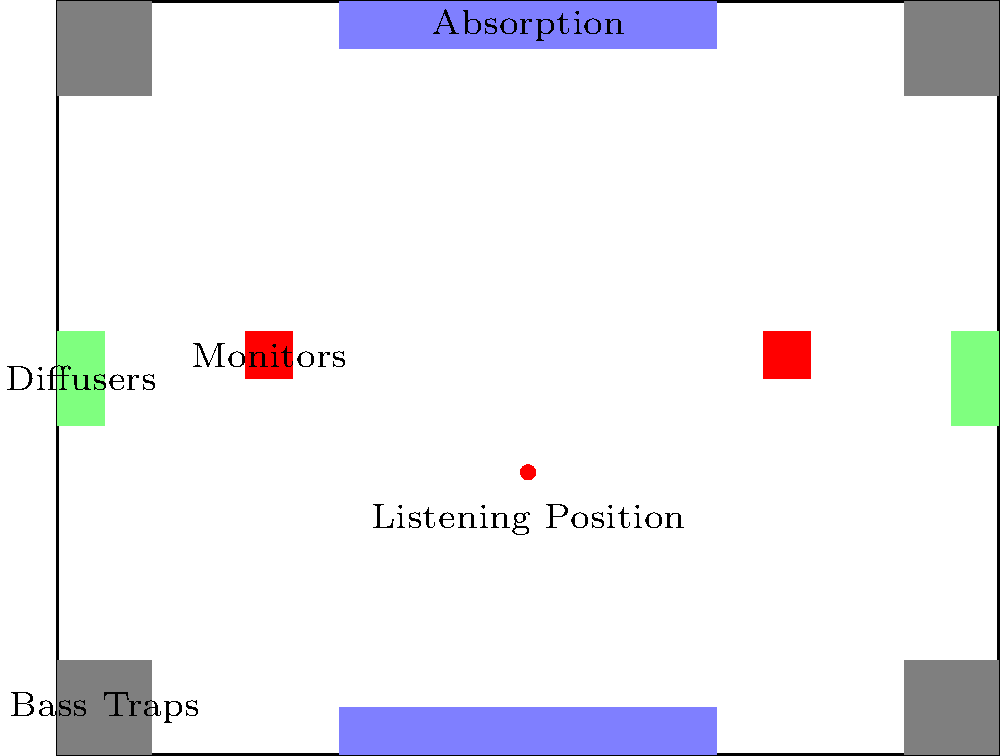As a record producer aiming to create a well-balanced acoustic environment, which element in the studio room layout is crucial for controlling low-frequency resonances and should be placed in the corners? To answer this question, let's analyze the elements in the studio room acoustic treatment layout:

1. The gray triangular shapes in the corners of the room represent bass traps.
2. The light blue rectangles on the ceiling and floor are absorption panels.
3. The light green rectangles on the side walls are diffusers.
4. The red squares represent monitor speakers.
5. The red dot indicates the listening position.

Bass traps are specifically designed to control low-frequency resonances in a room. They are most effective when placed in corners because:

a) Corners are where sound waves converge and create the strongest low-frequency buildup.
b) Bass frequencies have long wavelengths and tend to accumulate in corners.
c) Placing bass traps in corners maximizes their surface area exposure to sound waves.

By absorbing these low-frequency resonances, bass traps help to:

1. Reduce room modes and standing waves
2. Improve overall frequency response
3. Enhance the accuracy of monitoring and mixing

Other elements in the room, such as absorption panels and diffusers, serve different purposes:
- Absorption panels primarily deal with mid to high frequencies
- Diffusers help to scatter sound reflections and create a more even sound field

While all these elements contribute to a well-balanced acoustic environment, bass traps are specifically crucial for controlling low-frequency resonances.
Answer: Bass traps 